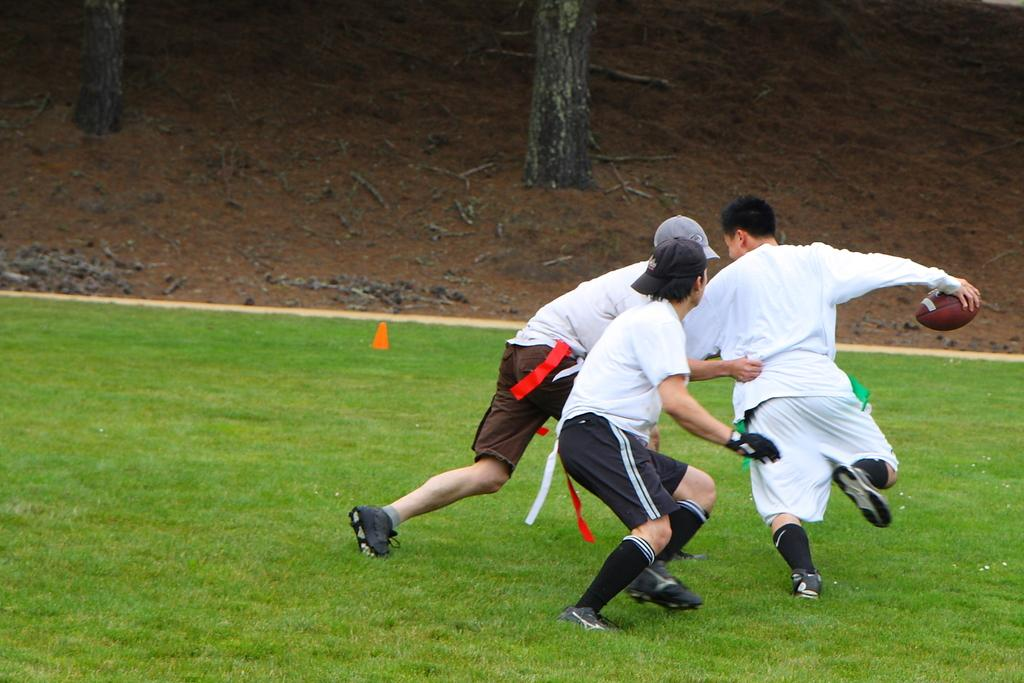What sport are the people playing in the image? The people are playing rugby in the image. What type of surface are they playing on? There is grass visible in the image, which suggests they are playing on a grassy field. What other material can be seen on the ground in the image? There is wood on the ground in the image. What is the weight of the wheel visible in the image? There is no wheel present in the image; it features people playing rugby on a grassy field with wood on the ground. 